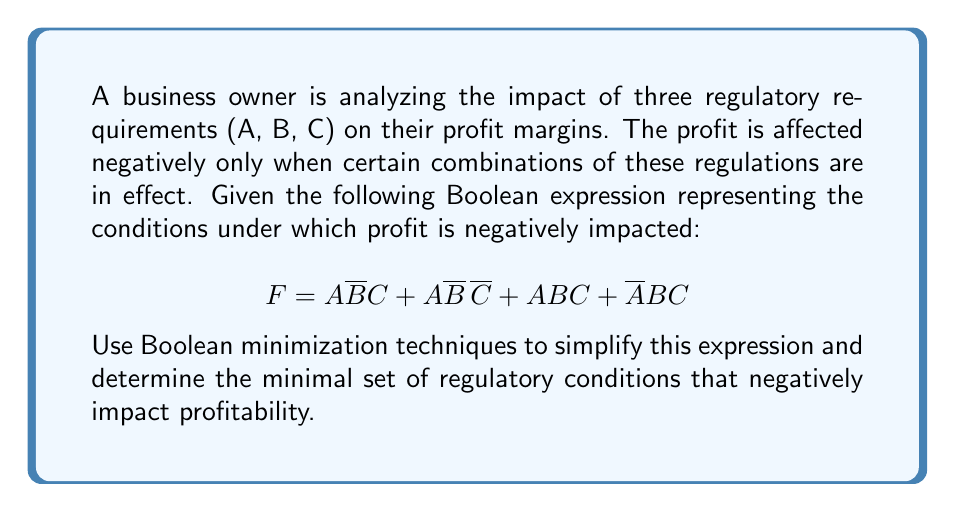Provide a solution to this math problem. Let's apply Boolean algebra minimization techniques to simplify the given expression:

1. Start with the original expression:
   $$ F = A\bar{B}C + A\bar{B}\bar{C} + ABC + \bar{A}BC $$

2. Group terms with common factors:
   $$ F = A\bar{B}(C + \bar{C}) + BC(A + \bar{A}) $$

3. Apply the Boolean identity $X + \bar{X} = 1$:
   $$ F = A\bar{B}(1) + BC(1) $$

4. Simplify:
   $$ F = A\bar{B} + BC $$

5. This expression cannot be further simplified using Boolean algebra.

The minimal expression $F = A\bar{B} + BC$ represents the simplified conditions under which profit is negatively impacted.

Interpretation for the business owner:
- $A\bar{B}$ means profit is negatively impacted when regulation A is in effect and B is not.
- $BC$ means profit is negatively impacted when both regulations B and C are in effect.

This simplification helps the business owner focus on the most critical regulatory combinations affecting profitability, potentially reducing compliance complexity and costs.
Answer: $$ F = A\bar{B} + BC $$ 